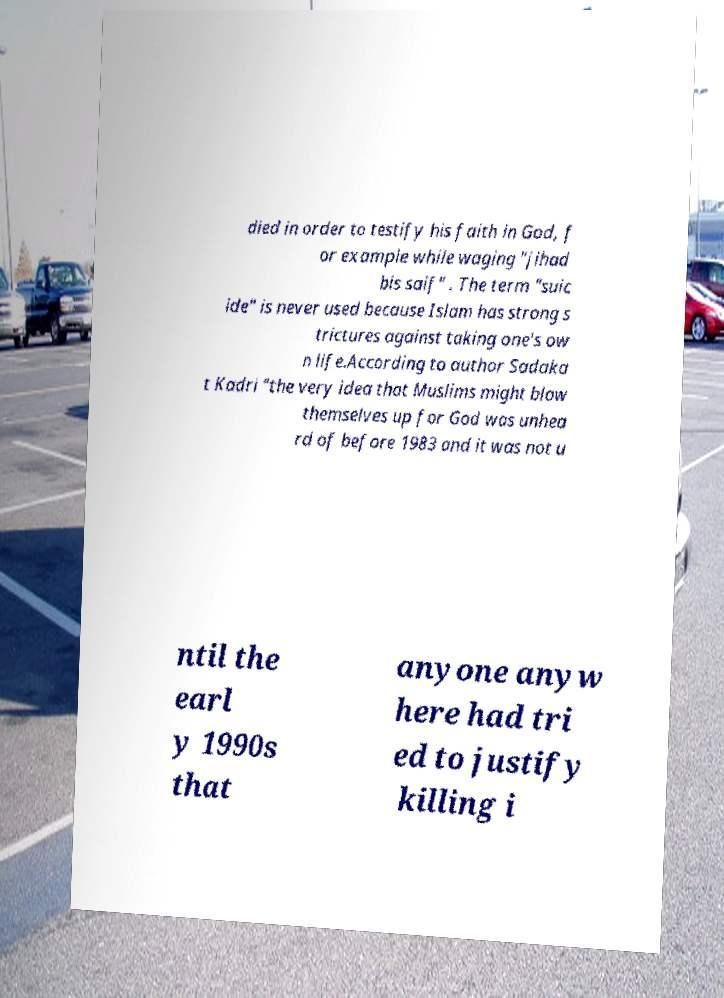Could you assist in decoding the text presented in this image and type it out clearly? died in order to testify his faith in God, f or example while waging "jihad bis saif" . The term "suic ide" is never used because Islam has strong s trictures against taking one's ow n life.According to author Sadaka t Kadri "the very idea that Muslims might blow themselves up for God was unhea rd of before 1983 and it was not u ntil the earl y 1990s that anyone anyw here had tri ed to justify killing i 